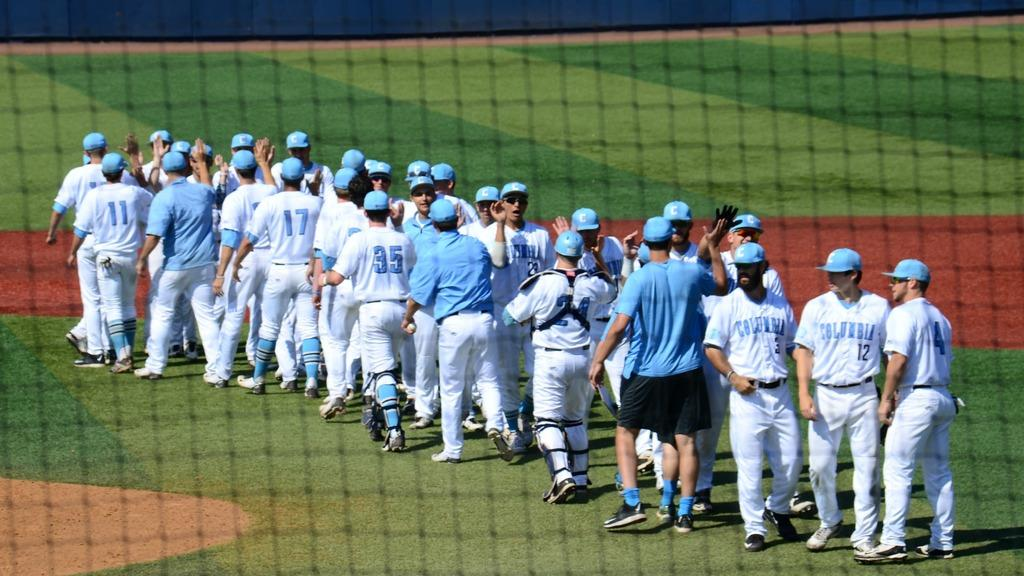Provide a one-sentence caption for the provided image. Baseball players greeting with each other including a catcher with number 24. 